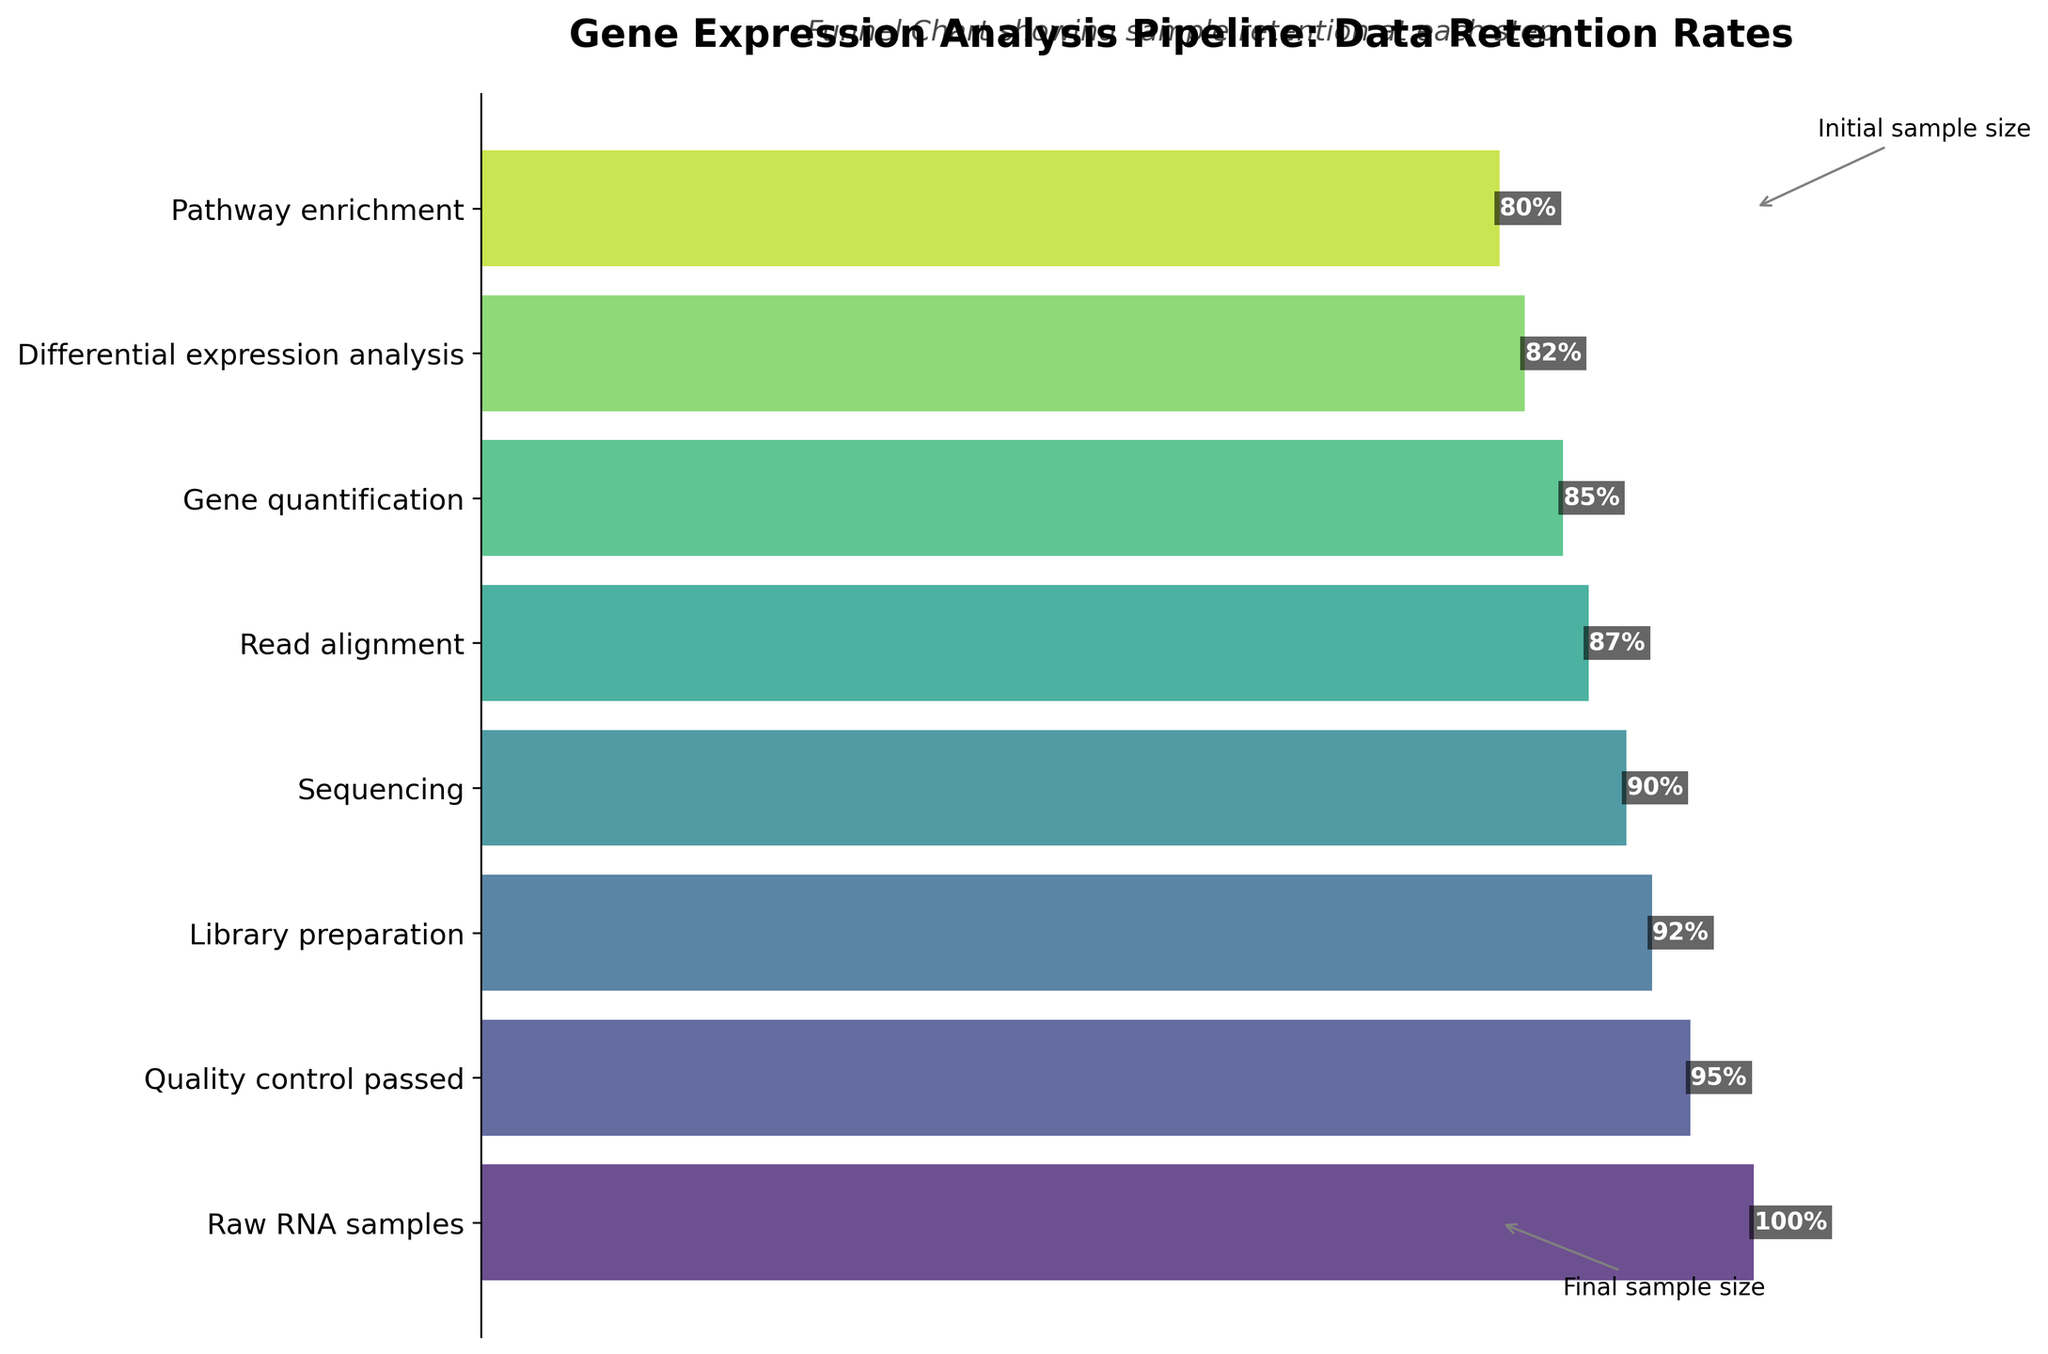What is the title of the plot? The title is usually one of the most prominent text elements situated at the top of the plot. It reads "Gene Expression Analysis Pipeline: Data Retention Rates."
Answer: Gene Expression Analysis Pipeline: Data Retention Rates What percentage of samples pass the Quality control step? This value is marked on the corresponding bar in the funnel chart. The step "Quality control passed" shows a retention rate of 95%.
Answer: 95% Which step has the lowest number of samples? By comparing the length of the bars horizontally, "Pathway enrichment" has the shortest bar, indicating it has the lowest number of samples.
Answer: Pathway enrichment How many samples were lost between the Library preparation and Sequencing steps? From the funnel chart, "Library preparation" has 920 samples, and "Sequencing" has 900 samples. The difference is 920 - 900.
Answer: 20 Which step sees the highest retention rate drop from the previous step? By calculating the drop in percentages between consecutive steps, the highest drop is from "Quality control passed" (95%) to "Library preparation" (92%), a difference of 3%.
Answer: Quality control passed to Library preparation What is the final sample size at Pathway enrichment? The funnel chart shows "Pathway enrichment" step retaining 800 samples.
Answer: 800 What is the average percentage retention rate across all the steps? To find the average, sum all the percentages and divide by the number of steps. (100 + 95 + 92 + 90 + 87 + 85 + 82 + 80) / 8 = 88.875
Answer: 88.875% How does the initial sample size compare to the final sample size? The initial sample size is 1000, and the final sample size is 800. The difference is 1000 - 800 = 200.
Answer: 200 fewer samples Which step retains more samples: Read alignment or Gene quantification? By comparing the sample numbers, "Read alignment" retains 870 samples while "Gene quantification" retains 850 samples.
Answer: Read alignment What annotation points out the initial sample size? The annotation at the top of the chart has an arrow pointing to the "Raw RNA samples" step and is labeled "Initial sample size."
Answer: Initial sample size 